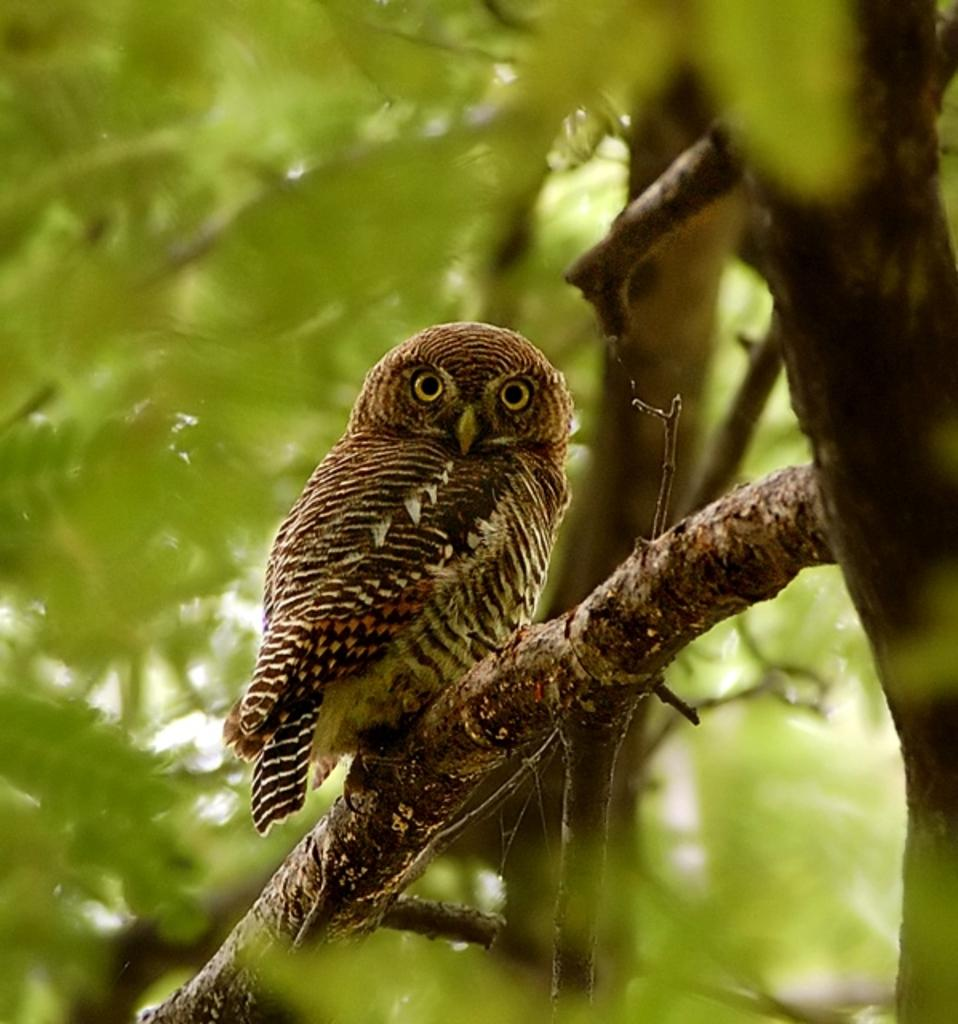What animal is present in the image? There is an owl in the image. Where is the owl located? The owl is on a branch of a tree. What can be seen in the background of the image? There are trees visible in the background of the image. What type of force is being applied to the oven in the image? There is no oven present in the image, so the question about force cannot be answered. 